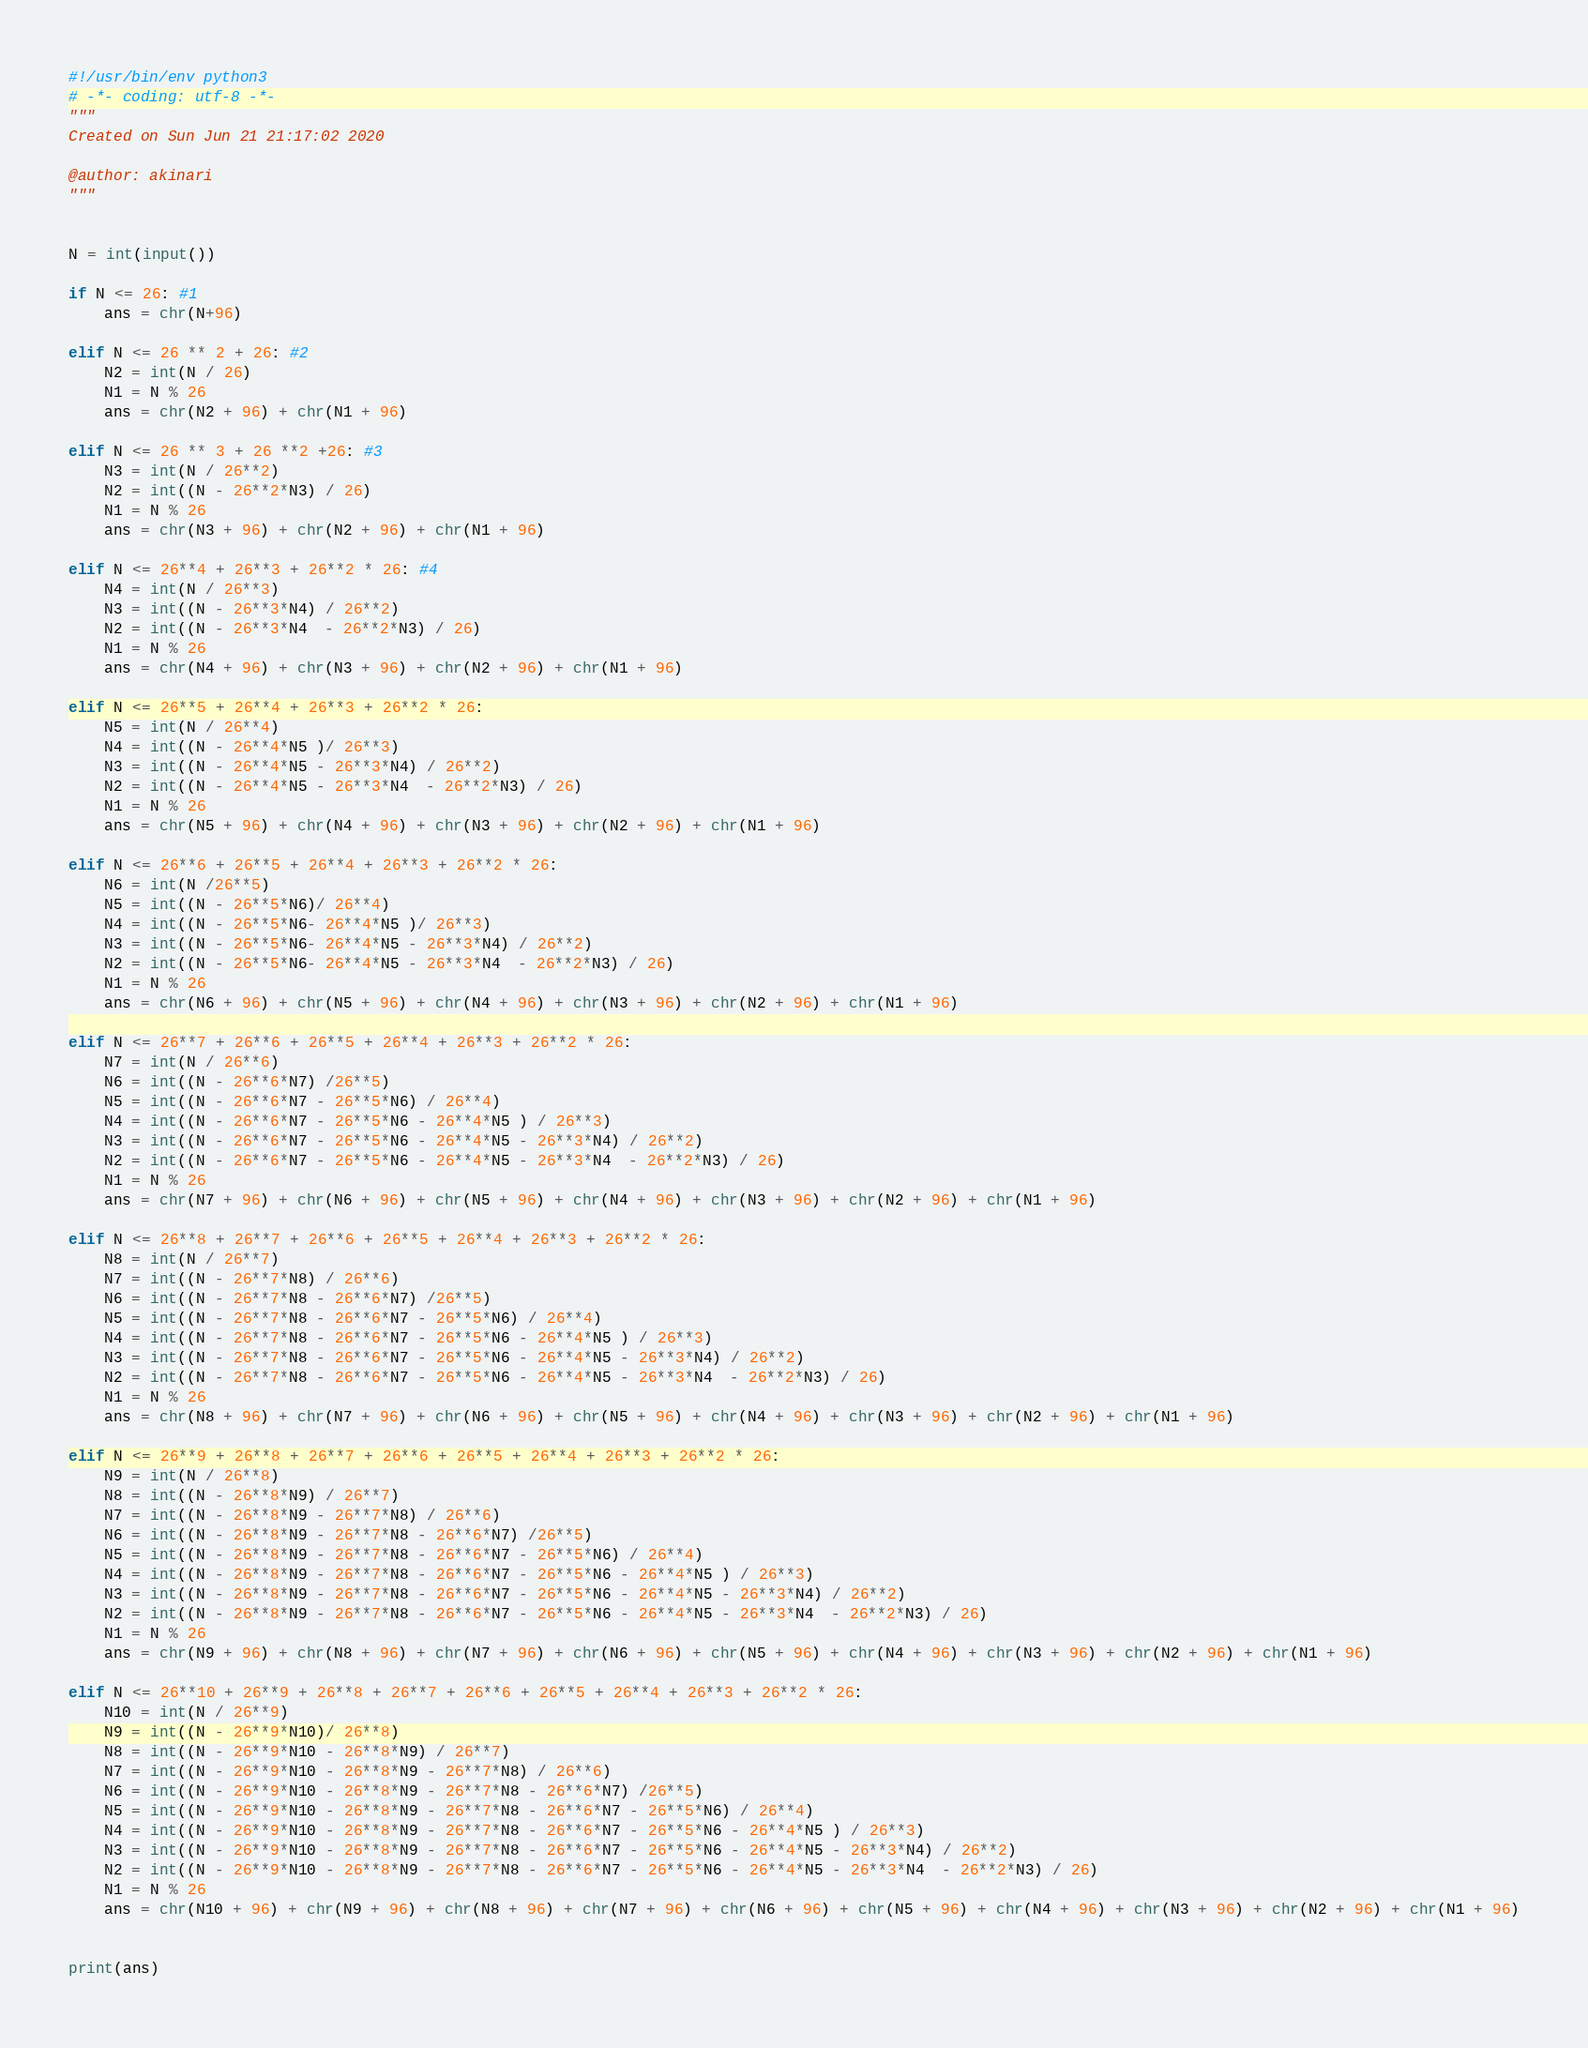Convert code to text. <code><loc_0><loc_0><loc_500><loc_500><_Python_>#!/usr/bin/env python3
# -*- coding: utf-8 -*-
"""
Created on Sun Jun 21 21:17:02 2020

@author: akinari
"""


N = int(input())

if N <= 26: #1
    ans = chr(N+96)
    
elif N <= 26 ** 2 + 26: #2
    N2 = int(N / 26)
    N1 = N % 26
    ans = chr(N2 + 96) + chr(N1 + 96)
    
elif N <= 26 ** 3 + 26 **2 +26: #3
    N3 = int(N / 26**2)
    N2 = int((N - 26**2*N3) / 26)
    N1 = N % 26
    ans = chr(N3 + 96) + chr(N2 + 96) + chr(N1 + 96)

elif N <= 26**4 + 26**3 + 26**2 * 26: #4
    N4 = int(N / 26**3)
    N3 = int((N - 26**3*N4) / 26**2)
    N2 = int((N - 26**3*N4  - 26**2*N3) / 26)
    N1 = N % 26
    ans = chr(N4 + 96) + chr(N3 + 96) + chr(N2 + 96) + chr(N1 + 96)
    
elif N <= 26**5 + 26**4 + 26**3 + 26**2 * 26:
    N5 = int(N / 26**4)
    N4 = int((N - 26**4*N5 )/ 26**3)
    N3 = int((N - 26**4*N5 - 26**3*N4) / 26**2)
    N2 = int((N - 26**4*N5 - 26**3*N4  - 26**2*N3) / 26)
    N1 = N % 26
    ans = chr(N5 + 96) + chr(N4 + 96) + chr(N3 + 96) + chr(N2 + 96) + chr(N1 + 96)
    
elif N <= 26**6 + 26**5 + 26**4 + 26**3 + 26**2 * 26:
    N6 = int(N /26**5)
    N5 = int((N - 26**5*N6)/ 26**4)
    N4 = int((N - 26**5*N6- 26**4*N5 )/ 26**3)
    N3 = int((N - 26**5*N6- 26**4*N5 - 26**3*N4) / 26**2)
    N2 = int((N - 26**5*N6- 26**4*N5 - 26**3*N4  - 26**2*N3) / 26)
    N1 = N % 26
    ans = chr(N6 + 96) + chr(N5 + 96) + chr(N4 + 96) + chr(N3 + 96) + chr(N2 + 96) + chr(N1 + 96)
    
elif N <= 26**7 + 26**6 + 26**5 + 26**4 + 26**3 + 26**2 * 26:
    N7 = int(N / 26**6)
    N6 = int((N - 26**6*N7) /26**5)
    N5 = int((N - 26**6*N7 - 26**5*N6) / 26**4)
    N4 = int((N - 26**6*N7 - 26**5*N6 - 26**4*N5 ) / 26**3)
    N3 = int((N - 26**6*N7 - 26**5*N6 - 26**4*N5 - 26**3*N4) / 26**2)
    N2 = int((N - 26**6*N7 - 26**5*N6 - 26**4*N5 - 26**3*N4  - 26**2*N3) / 26)
    N1 = N % 26
    ans = chr(N7 + 96) + chr(N6 + 96) + chr(N5 + 96) + chr(N4 + 96) + chr(N3 + 96) + chr(N2 + 96) + chr(N1 + 96)
    
elif N <= 26**8 + 26**7 + 26**6 + 26**5 + 26**4 + 26**3 + 26**2 * 26:
    N8 = int(N / 26**7)
    N7 = int((N - 26**7*N8) / 26**6)
    N6 = int((N - 26**7*N8 - 26**6*N7) /26**5)
    N5 = int((N - 26**7*N8 - 26**6*N7 - 26**5*N6) / 26**4)
    N4 = int((N - 26**7*N8 - 26**6*N7 - 26**5*N6 - 26**4*N5 ) / 26**3)
    N3 = int((N - 26**7*N8 - 26**6*N7 - 26**5*N6 - 26**4*N5 - 26**3*N4) / 26**2)
    N2 = int((N - 26**7*N8 - 26**6*N7 - 26**5*N6 - 26**4*N5 - 26**3*N4  - 26**2*N3) / 26)
    N1 = N % 26
    ans = chr(N8 + 96) + chr(N7 + 96) + chr(N6 + 96) + chr(N5 + 96) + chr(N4 + 96) + chr(N3 + 96) + chr(N2 + 96) + chr(N1 + 96)
    
elif N <= 26**9 + 26**8 + 26**7 + 26**6 + 26**5 + 26**4 + 26**3 + 26**2 * 26:
    N9 = int(N / 26**8)
    N8 = int((N - 26**8*N9) / 26**7)
    N7 = int((N - 26**8*N9 - 26**7*N8) / 26**6)
    N6 = int((N - 26**8*N9 - 26**7*N8 - 26**6*N7) /26**5)
    N5 = int((N - 26**8*N9 - 26**7*N8 - 26**6*N7 - 26**5*N6) / 26**4)
    N4 = int((N - 26**8*N9 - 26**7*N8 - 26**6*N7 - 26**5*N6 - 26**4*N5 ) / 26**3)
    N3 = int((N - 26**8*N9 - 26**7*N8 - 26**6*N7 - 26**5*N6 - 26**4*N5 - 26**3*N4) / 26**2)
    N2 = int((N - 26**8*N9 - 26**7*N8 - 26**6*N7 - 26**5*N6 - 26**4*N5 - 26**3*N4  - 26**2*N3) / 26)
    N1 = N % 26
    ans = chr(N9 + 96) + chr(N8 + 96) + chr(N7 + 96) + chr(N6 + 96) + chr(N5 + 96) + chr(N4 + 96) + chr(N3 + 96) + chr(N2 + 96) + chr(N1 + 96)
 
elif N <= 26**10 + 26**9 + 26**8 + 26**7 + 26**6 + 26**5 + 26**4 + 26**3 + 26**2 * 26:
    N10 = int(N / 26**9)
    N9 = int((N - 26**9*N10)/ 26**8)
    N8 = int((N - 26**9*N10 - 26**8*N9) / 26**7)
    N7 = int((N - 26**9*N10 - 26**8*N9 - 26**7*N8) / 26**6)
    N6 = int((N - 26**9*N10 - 26**8*N9 - 26**7*N8 - 26**6*N7) /26**5)
    N5 = int((N - 26**9*N10 - 26**8*N9 - 26**7*N8 - 26**6*N7 - 26**5*N6) / 26**4)
    N4 = int((N - 26**9*N10 - 26**8*N9 - 26**7*N8 - 26**6*N7 - 26**5*N6 - 26**4*N5 ) / 26**3)
    N3 = int((N - 26**9*N10 - 26**8*N9 - 26**7*N8 - 26**6*N7 - 26**5*N6 - 26**4*N5 - 26**3*N4) / 26**2)
    N2 = int((N - 26**9*N10 - 26**8*N9 - 26**7*N8 - 26**6*N7 - 26**5*N6 - 26**4*N5 - 26**3*N4  - 26**2*N3) / 26)
    N1 = N % 26
    ans = chr(N10 + 96) + chr(N9 + 96) + chr(N8 + 96) + chr(N7 + 96) + chr(N6 + 96) + chr(N5 + 96) + chr(N4 + 96) + chr(N3 + 96) + chr(N2 + 96) + chr(N1 + 96)
   
    
print(ans)

















</code> 